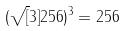<formula> <loc_0><loc_0><loc_500><loc_500>( \sqrt { [ } 3 ] { 2 5 6 } ) ^ { 3 } = 2 5 6</formula> 